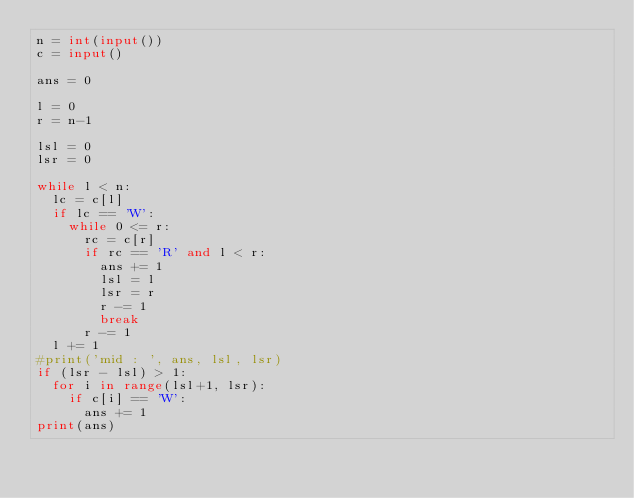Convert code to text. <code><loc_0><loc_0><loc_500><loc_500><_Python_>n = int(input())
c = input()

ans = 0

l = 0
r = n-1

lsl = 0
lsr = 0

while l < n:
  lc = c[l]
  if lc == 'W':
    while 0 <= r:
      rc = c[r]
      if rc == 'R' and l < r:
        ans += 1
        lsl = l
        lsr = r
        r -= 1
        break
      r -= 1
  l += 1
#print('mid : ', ans, lsl, lsr)
if (lsr - lsl) > 1:
  for i in range(lsl+1, lsr):
    if c[i] == 'W':
      ans += 1
print(ans)</code> 